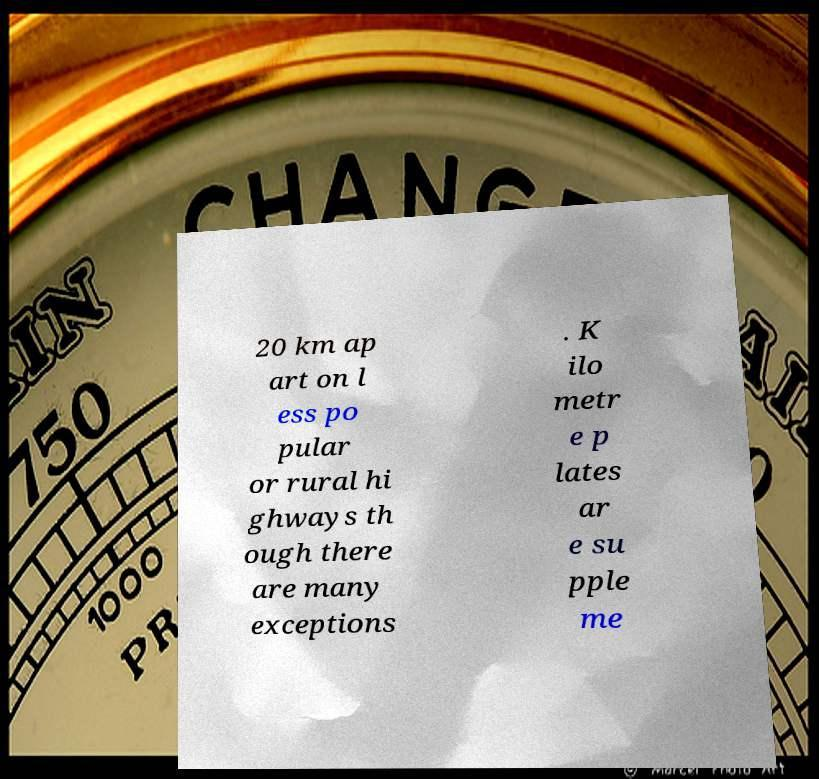There's text embedded in this image that I need extracted. Can you transcribe it verbatim? 20 km ap art on l ess po pular or rural hi ghways th ough there are many exceptions . K ilo metr e p lates ar e su pple me 